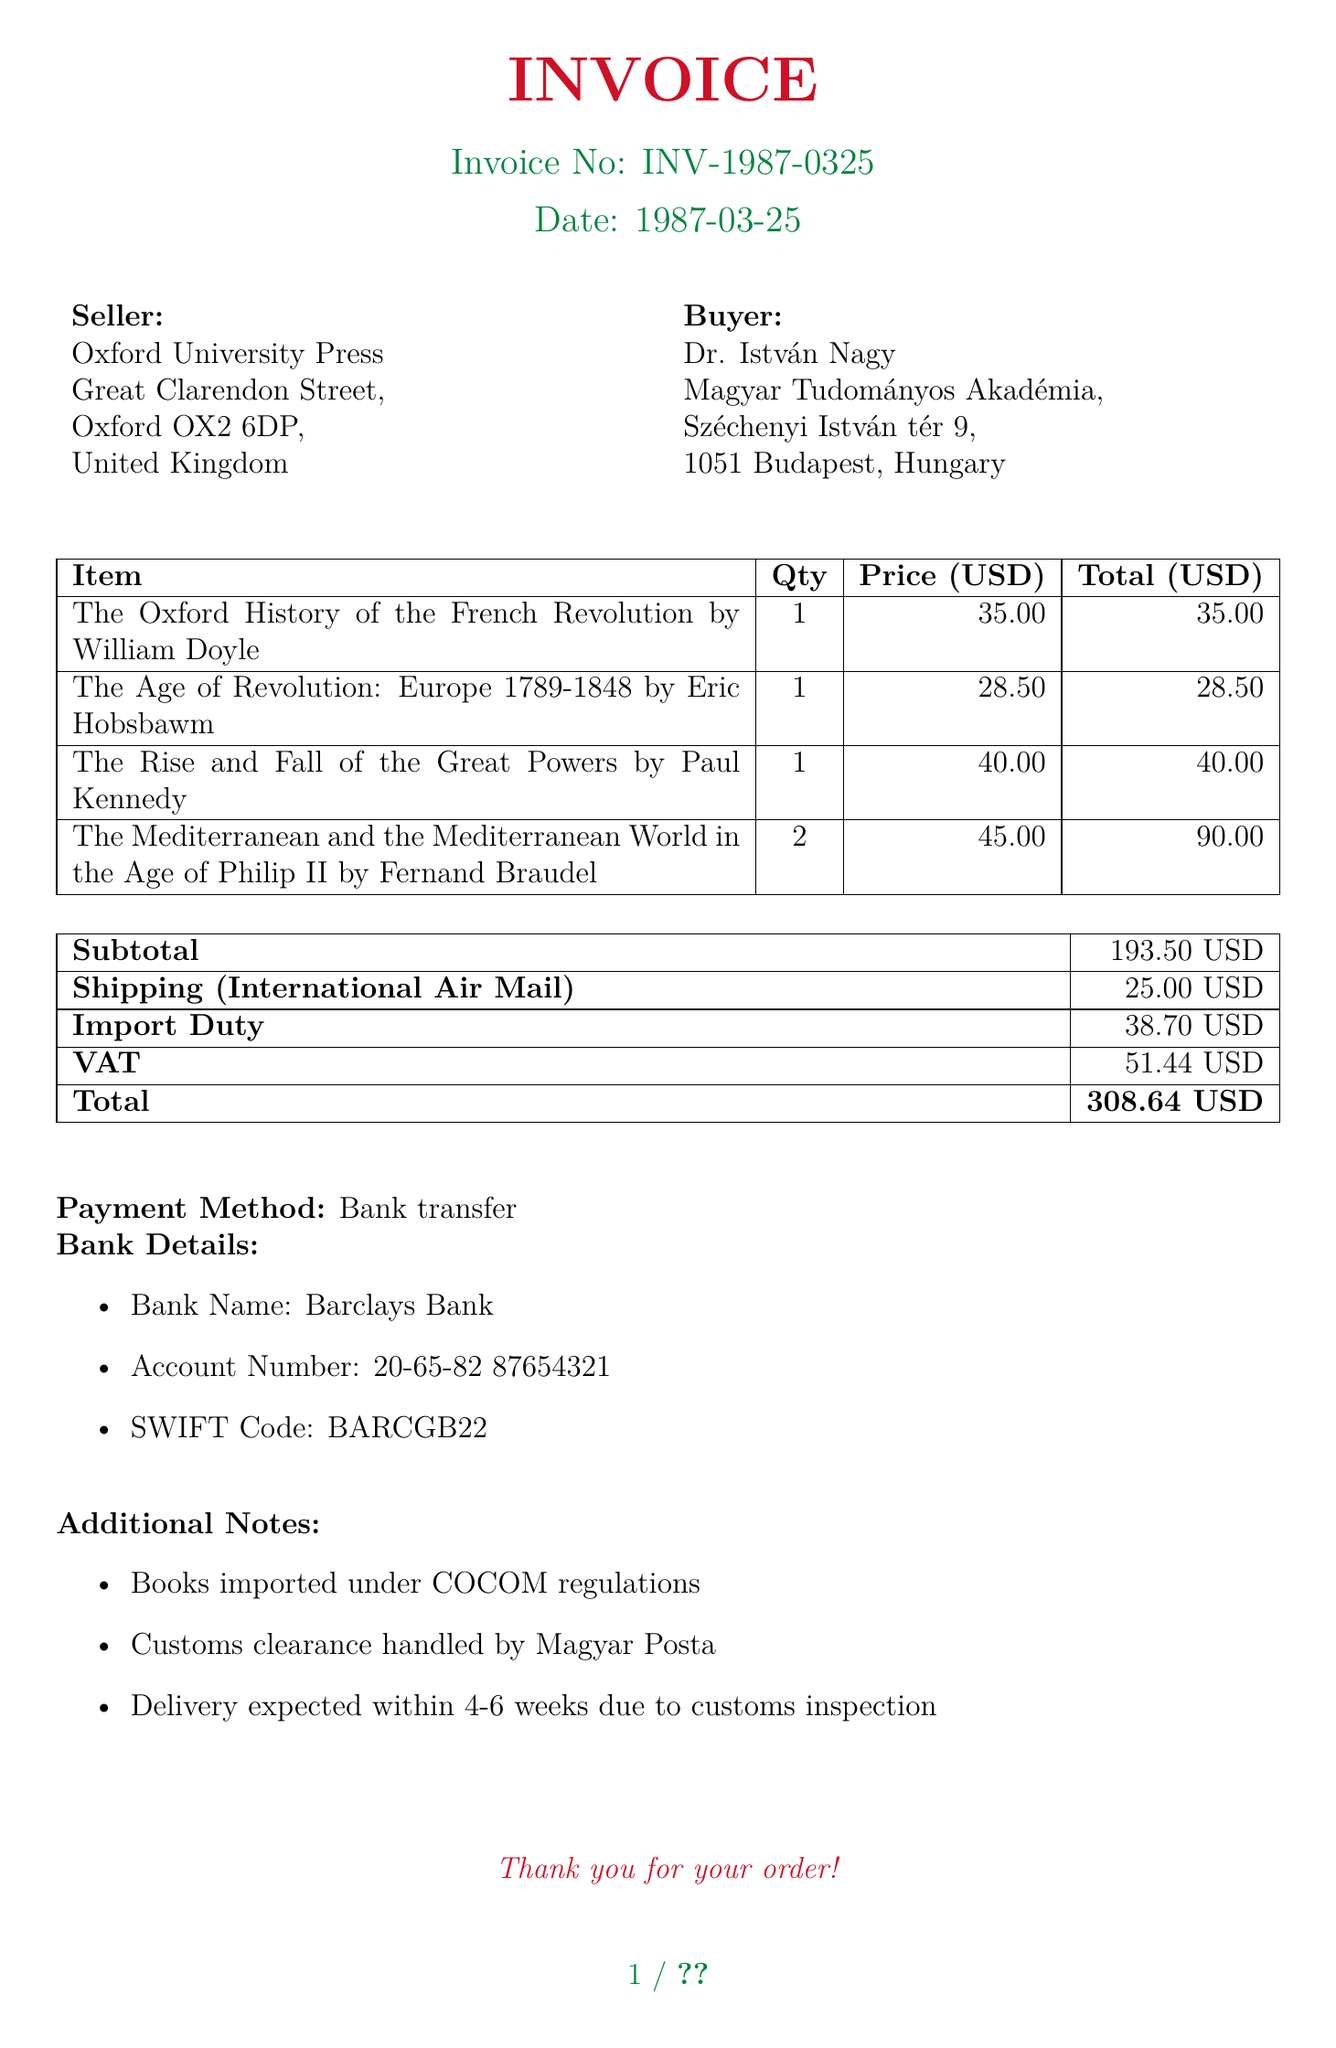What is the invoice number? The invoice number is a unique identifier for the document, indicated clearly in the header section.
Answer: INV-1987-0325 Who is the seller? The seller is listed in the document as the entity providing the goods, specifically noted under the seller section.
Answer: Oxford University Press What is the subtotal amount? The subtotal is the sum of the prices of the books before any additional charges like shipping or customs fees.
Answer: 193.50 USD What is the total amount due? The total is the final amount payable including all fees and charges, clearly listed at the end of the document.
Answer: 308.64 USD What is the delivery method? The delivery method is mentioned in the shipping section of the invoice, detailing how the goods will be transported.
Answer: International Air Mail What is the VAT amount? The VAT amount is a specific fee included in the customs fees that reflects the value-added tax applied to the imported goods.
Answer: 51.44 USD How many books are purchased from Fernand Braudel? The document provides details about each item purchased, including the quantity for each title.
Answer: 2 What are the payment details? Payment details are given in a specific section and include the bank's information required for the transaction.
Answer: Bank transfer What is the expected delivery time? The document notes an estimated timeframe for delivery, providing context about potential delays.
Answer: 4-6 weeks 